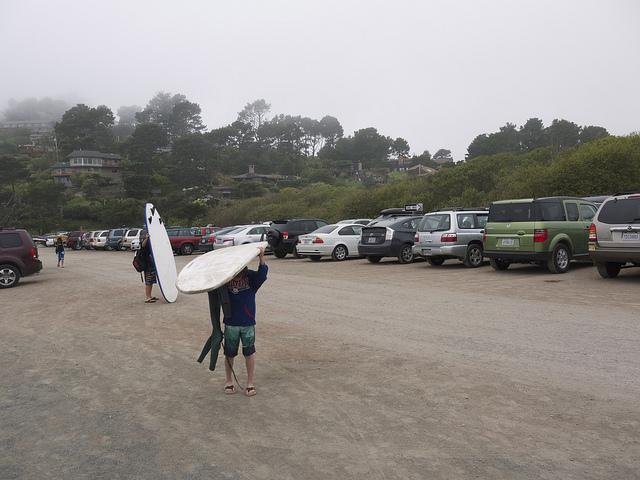Where are persons carrying the white items going?

Choices:
A) pool hall
B) swimming pool
C) ocean
D) bar ocean 